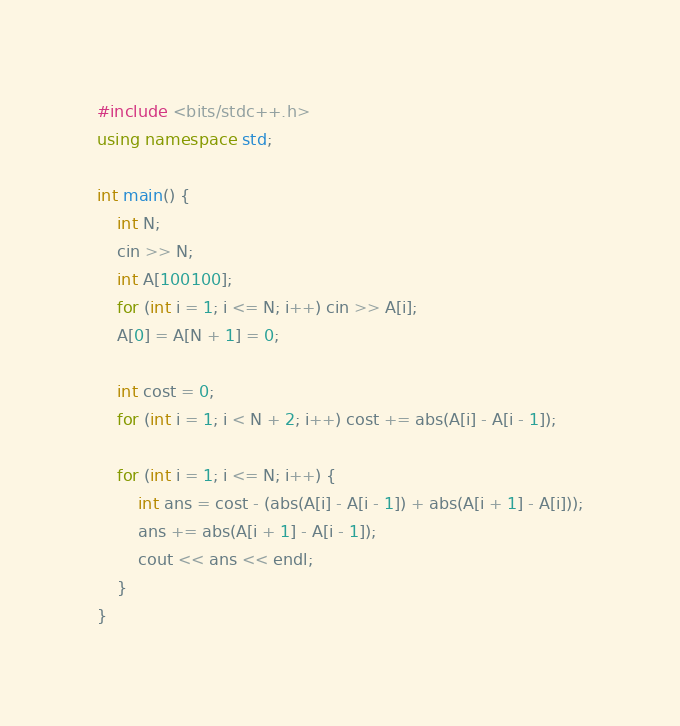Convert code to text. <code><loc_0><loc_0><loc_500><loc_500><_C++_>#include <bits/stdc++.h>
using namespace std;

int main() {
    int N;
    cin >> N;
    int A[100100];
    for (int i = 1; i <= N; i++) cin >> A[i];
    A[0] = A[N + 1] = 0;

    int cost = 0;
    for (int i = 1; i < N + 2; i++) cost += abs(A[i] - A[i - 1]);

    for (int i = 1; i <= N; i++) {
        int ans = cost - (abs(A[i] - A[i - 1]) + abs(A[i + 1] - A[i]));
        ans += abs(A[i + 1] - A[i - 1]);
        cout << ans << endl;
    }
}</code> 